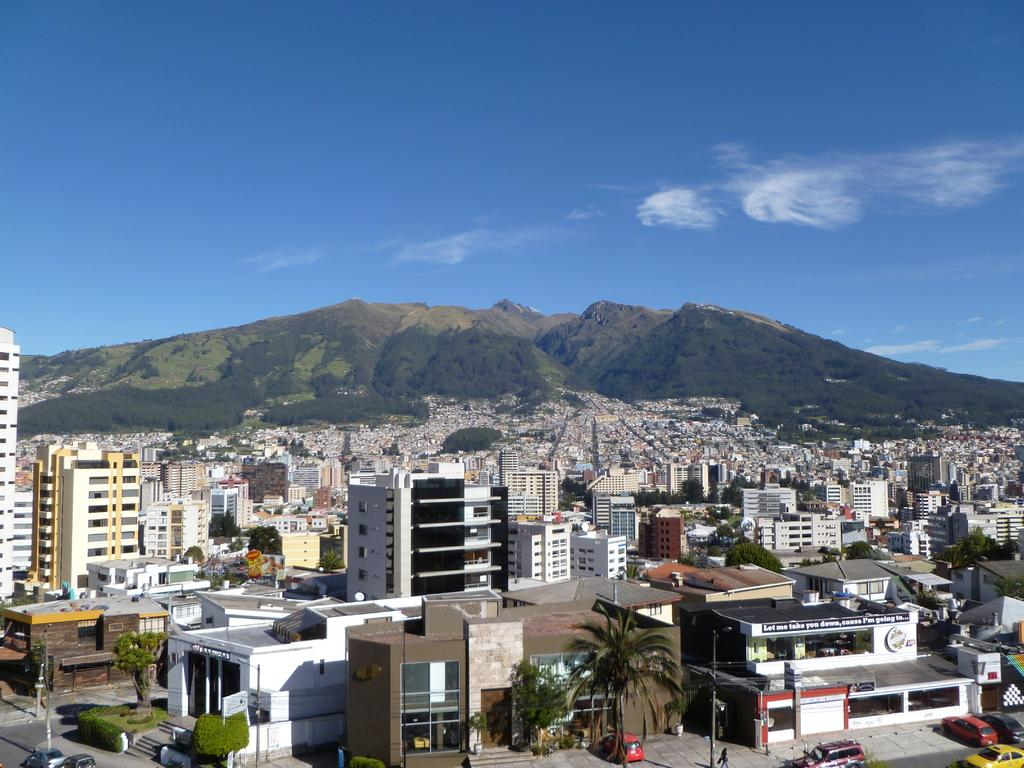What types of structures can be seen in the image? There are buildings in the image. What other natural elements are present in the image? There are plants, trees, and a mountain visible in the image. What man-made objects can be seen in the image? There are poles, boards, and vehicles in the image. What is the condition of the sky in the background? The sky is visible in the background, and clouds are present. What is the primary mode of transportation in the image? Vehicles are present in the image, suggesting that they are the primary mode of transportation. What time of day is it in the image, and what is the father doing? The time of day is not mentioned in the image, and there is no father present in the image. How does the pain manifest itself in the image? There is no mention of pain in the image. 